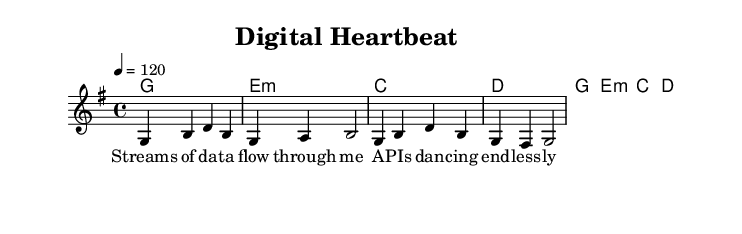What is the key signature of this music? The key signature indicated in the global section shows one sharp, which is characteristic of G major.
Answer: G major What is the time signature of this piece? The time signature displayed in the global section is 4/4, which means there are four beats per measure.
Answer: 4/4 What is the tempo marking for this song? The tempo is indicated at 120 beats per minute, which is a relatively moderate tempo for the piece.
Answer: 120 How many measures are in the melody? By counting each measure indicated in the staff of the melody, there are a total of four measures.
Answer: Four What is the first lyric line of the song? The first lyric line is "Streams of da -- ta flow through me," as shown in the lyrics section corresponding to the melody.
Answer: Streams of da -- ta flow through me What type of chord is used in the first measure? The first chord indicated is a G major chord, as it is the chord listed in the harmonies section.
Answer: G major How many notes are in the fourth measure of the melody? Counting the notes in the fourth measure reveals that there are four notes present.
Answer: Four 